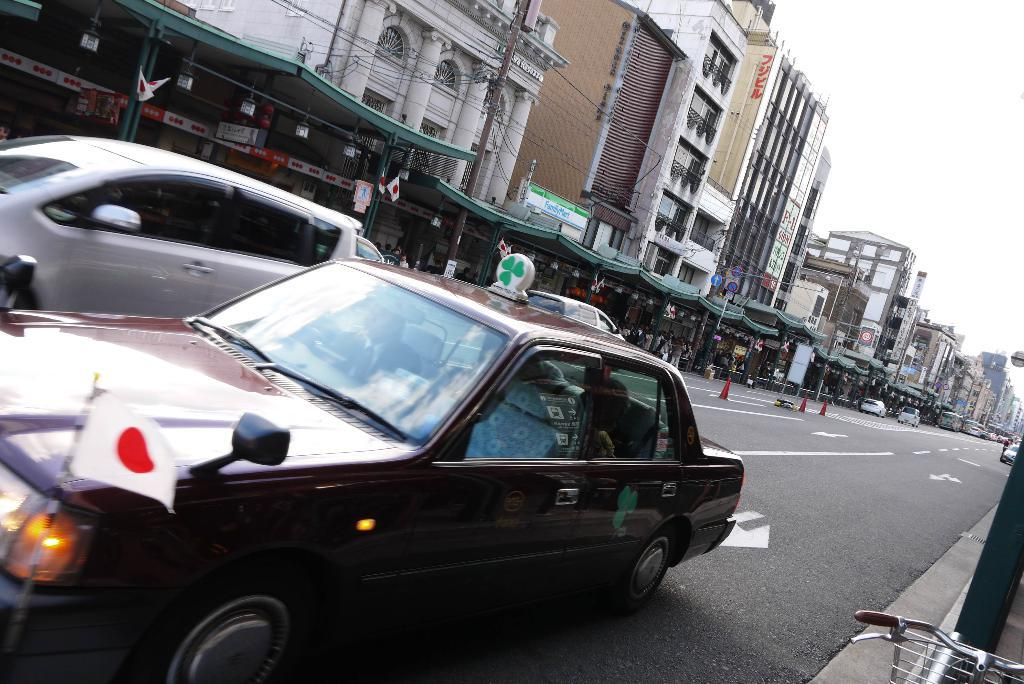What is: What is the main subject of the image? The main subject of the image is a car. What is the car doing in the image? The car is moving on the road in the image. What is the color of the car? The car is dark red in color. What can be seen on the left side of the image? There are selling stores on the left side of the image. What type of structures are present in the image? There are buildings in the image. What type of shirt is the plane wearing in the image? There is no plane present in the image, so it is not possible to determine what type of shirt it might be wearing. 